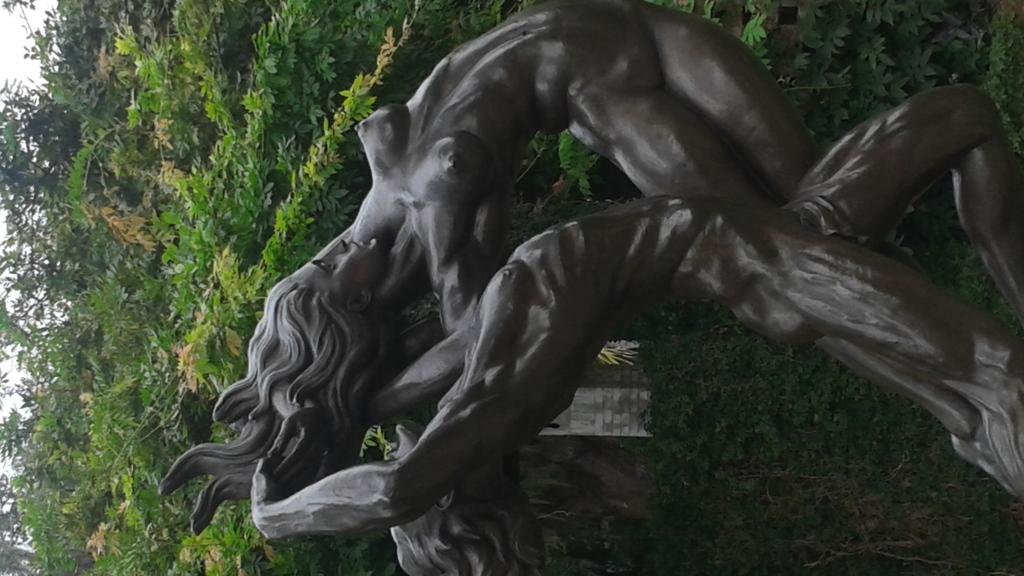What is the main subject in the foreground of the image? There is a statue in the foreground of the image. What can be seen in the background of the image? There are plants and a house in the background of the image. How many balls are being juggled by the statue in the image? There are no balls present in the image; the statue is not juggling anything. 